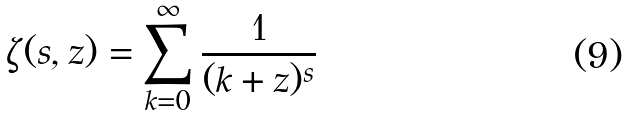Convert formula to latex. <formula><loc_0><loc_0><loc_500><loc_500>\zeta ( s , z ) = \sum _ { k = 0 } ^ { \infty } \frac { 1 } { ( k + z ) ^ { s } }</formula> 